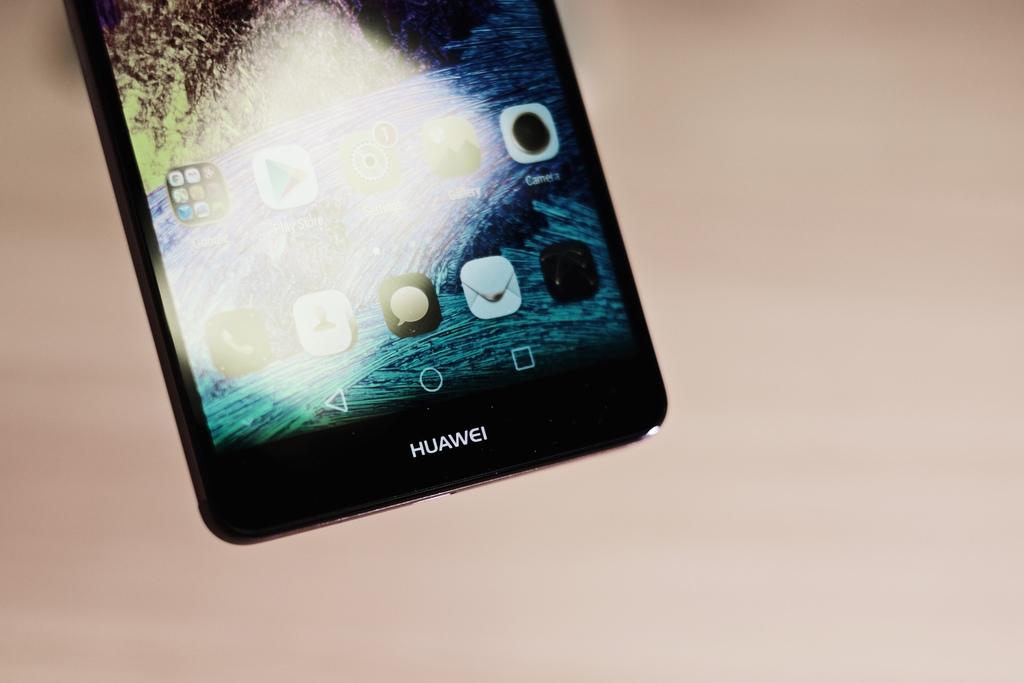Who made the cell phone?
Ensure brevity in your answer.  Huawei. 